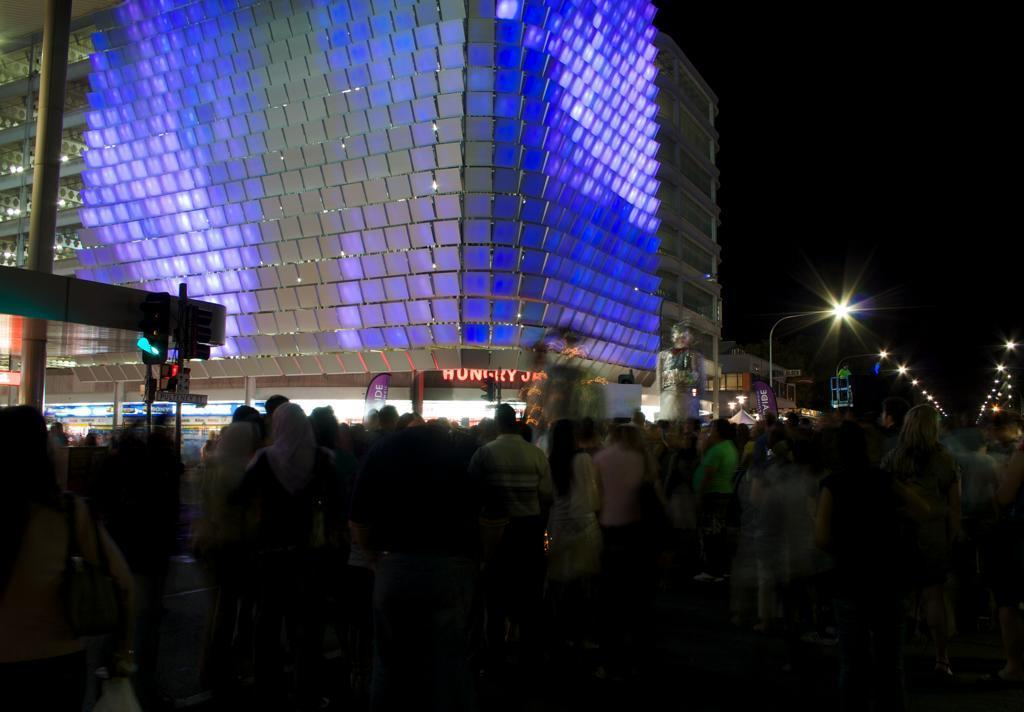What types of people are present in the image? There are men and women standing in the image. What can be seen in the background of the image? There are signal lights, street lights, a pole, a statue, and buildings in the background of the image. What type of cap is the glass wearing in the image? There is no glass or cap present in the image. What is the relation between the statue and the buildings in the image? The provided facts do not mention any relation between the statue and the buildings; they are simply two separate elements in the background of the image. 